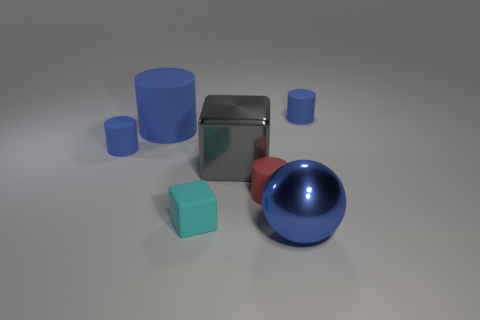Subtract all red cylinders. How many cylinders are left? 3 Subtract 2 cylinders. How many cylinders are left? 2 Subtract all blue blocks. How many blue cylinders are left? 3 Subtract all small cylinders. How many cylinders are left? 1 Add 1 tiny green cubes. How many objects exist? 8 Subtract all brown cylinders. Subtract all red blocks. How many cylinders are left? 4 Subtract all large blue rubber cylinders. Subtract all balls. How many objects are left? 5 Add 7 large blue cylinders. How many large blue cylinders are left? 8 Add 5 cylinders. How many cylinders exist? 9 Subtract 0 purple cylinders. How many objects are left? 7 